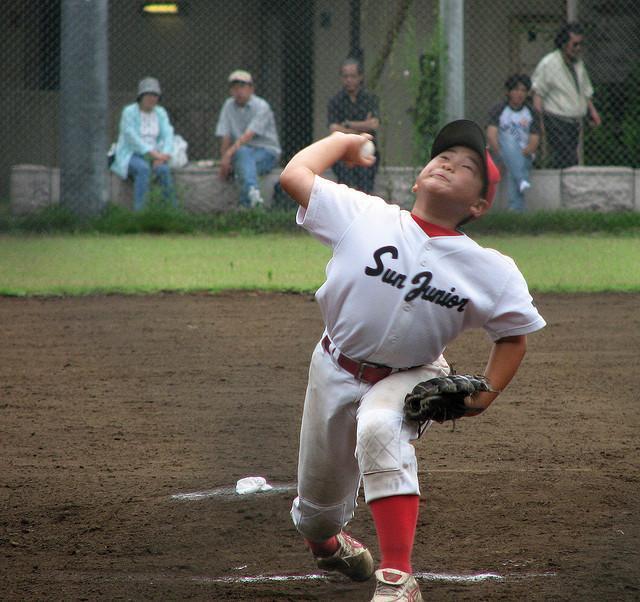How many people can you see?
Give a very brief answer. 6. 